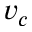Convert formula to latex. <formula><loc_0><loc_0><loc_500><loc_500>v _ { c }</formula> 